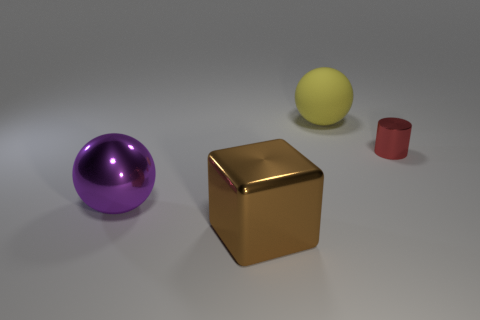Is there anything else that has the same material as the yellow object?
Make the answer very short. No. Are the ball that is to the left of the rubber sphere and the big thing behind the small red metallic cylinder made of the same material?
Your response must be concise. No. What material is the sphere behind the large metal object behind the big brown object?
Provide a short and direct response. Rubber. There is a thing behind the thing on the right side of the big thing behind the big purple ball; what is its size?
Your response must be concise. Large. Do the yellow thing and the red cylinder have the same size?
Your answer should be compact. No. Is the shape of the metallic thing on the left side of the big brown block the same as the thing behind the small red thing?
Ensure brevity in your answer.  Yes. Is there a metallic ball left of the big ball in front of the tiny red metallic cylinder?
Offer a terse response. No. Is there a yellow rubber thing?
Offer a terse response. Yes. What number of other brown metal blocks have the same size as the block?
Give a very brief answer. 0. How many things are both to the right of the purple shiny sphere and behind the large brown object?
Make the answer very short. 2. 